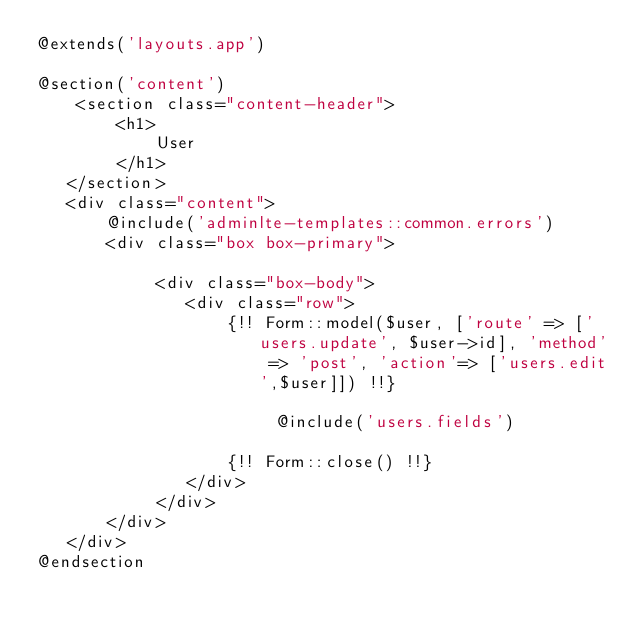<code> <loc_0><loc_0><loc_500><loc_500><_PHP_>@extends('layouts.app')

@section('content')
    <section class="content-header">
        <h1>
            User
        </h1>
   </section>
   <div class="content">
       @include('adminlte-templates::common.errors')
       <div class="box box-primary">
            
            <div class="box-body">
               <div class="row">
                   {!! Form::model($user, ['route' => ['users.update', $user->id], 'method' => 'post', 'action'=> ['users.edit',$user]]) !!}

                        @include('users.fields')

                   {!! Form::close() !!}
               </div>
            </div>
       </div>
   </div>
@endsection</code> 